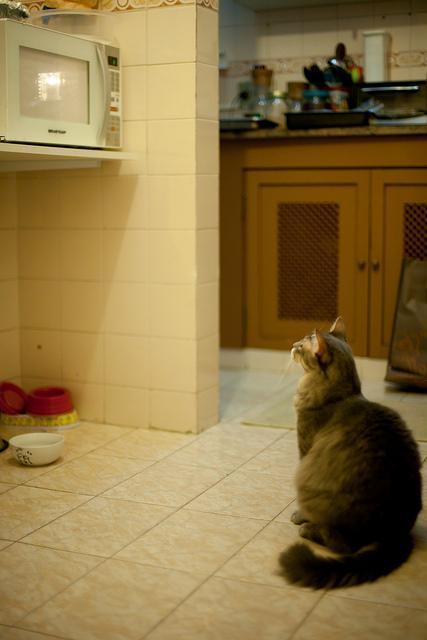How many people are on the boat not at the dock?
Give a very brief answer. 0. 